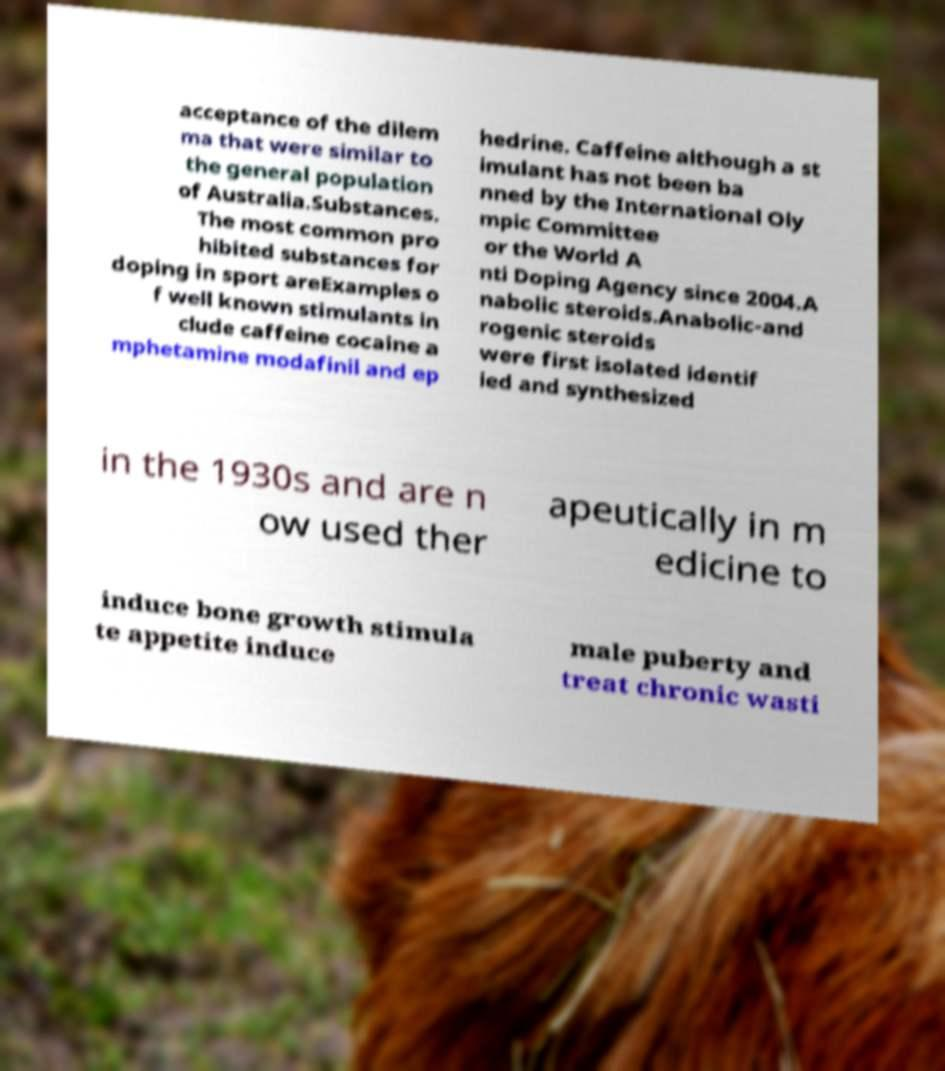What messages or text are displayed in this image? I need them in a readable, typed format. acceptance of the dilem ma that were similar to the general population of Australia.Substances. The most common pro hibited substances for doping in sport areExamples o f well known stimulants in clude caffeine cocaine a mphetamine modafinil and ep hedrine. Caffeine although a st imulant has not been ba nned by the International Oly mpic Committee or the World A nti Doping Agency since 2004.A nabolic steroids.Anabolic-and rogenic steroids were first isolated identif ied and synthesized in the 1930s and are n ow used ther apeutically in m edicine to induce bone growth stimula te appetite induce male puberty and treat chronic wasti 